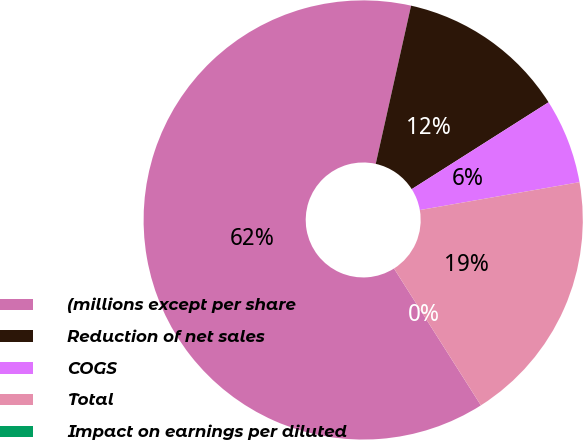Convert chart to OTSL. <chart><loc_0><loc_0><loc_500><loc_500><pie_chart><fcel>(millions except per share<fcel>Reduction of net sales<fcel>COGS<fcel>Total<fcel>Impact on earnings per diluted<nl><fcel>62.5%<fcel>12.5%<fcel>6.25%<fcel>18.75%<fcel>0.0%<nl></chart> 